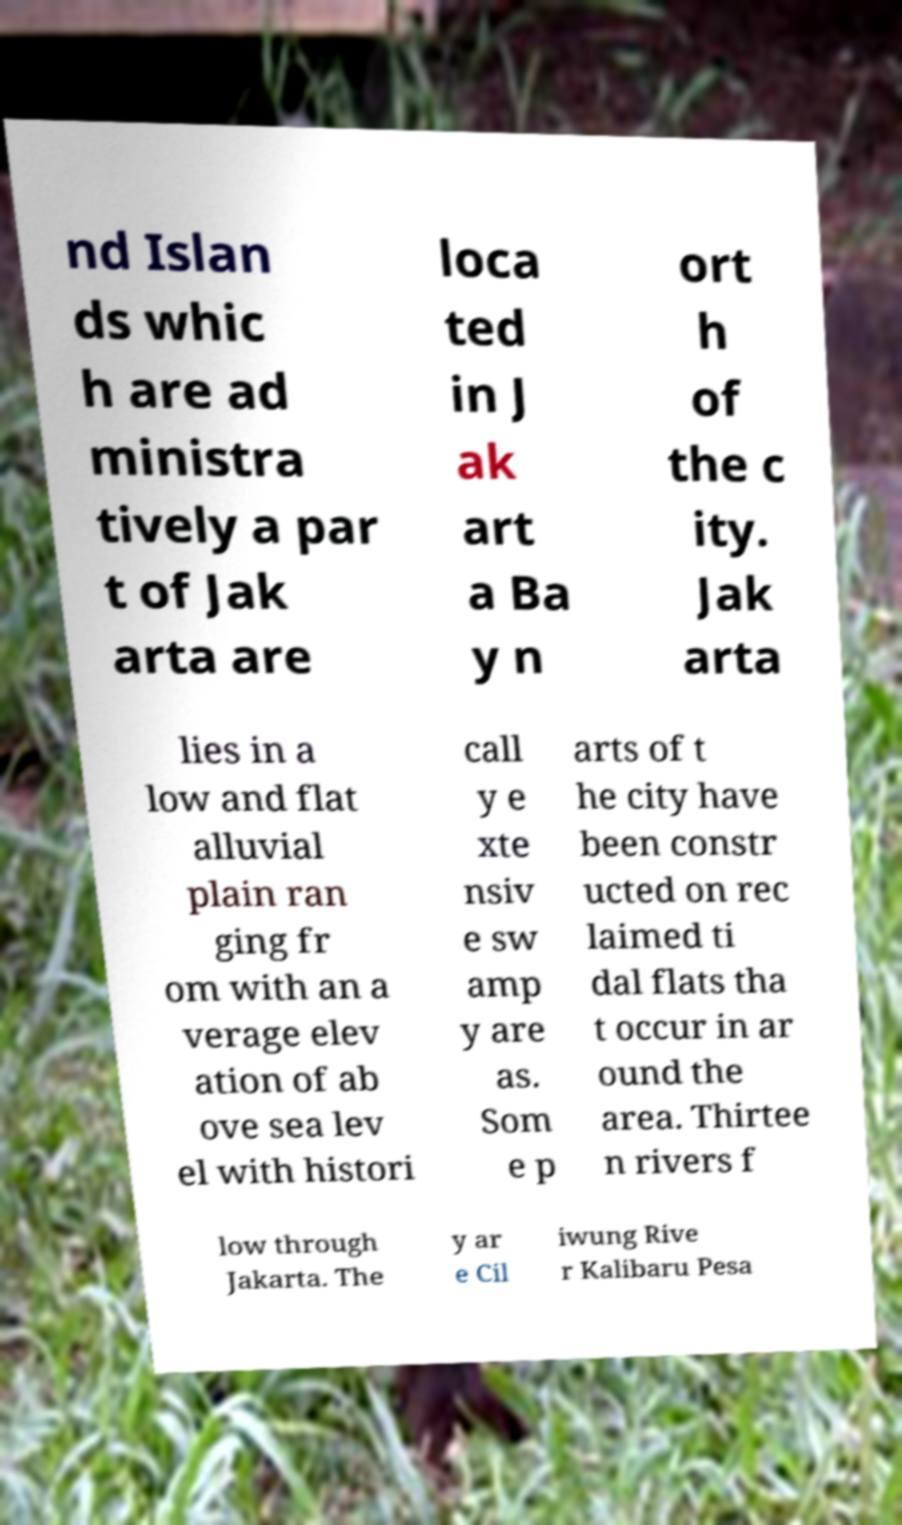Can you read and provide the text displayed in the image?This photo seems to have some interesting text. Can you extract and type it out for me? nd Islan ds whic h are ad ministra tively a par t of Jak arta are loca ted in J ak art a Ba y n ort h of the c ity. Jak arta lies in a low and flat alluvial plain ran ging fr om with an a verage elev ation of ab ove sea lev el with histori call y e xte nsiv e sw amp y are as. Som e p arts of t he city have been constr ucted on rec laimed ti dal flats tha t occur in ar ound the area. Thirtee n rivers f low through Jakarta. The y ar e Cil iwung Rive r Kalibaru Pesa 